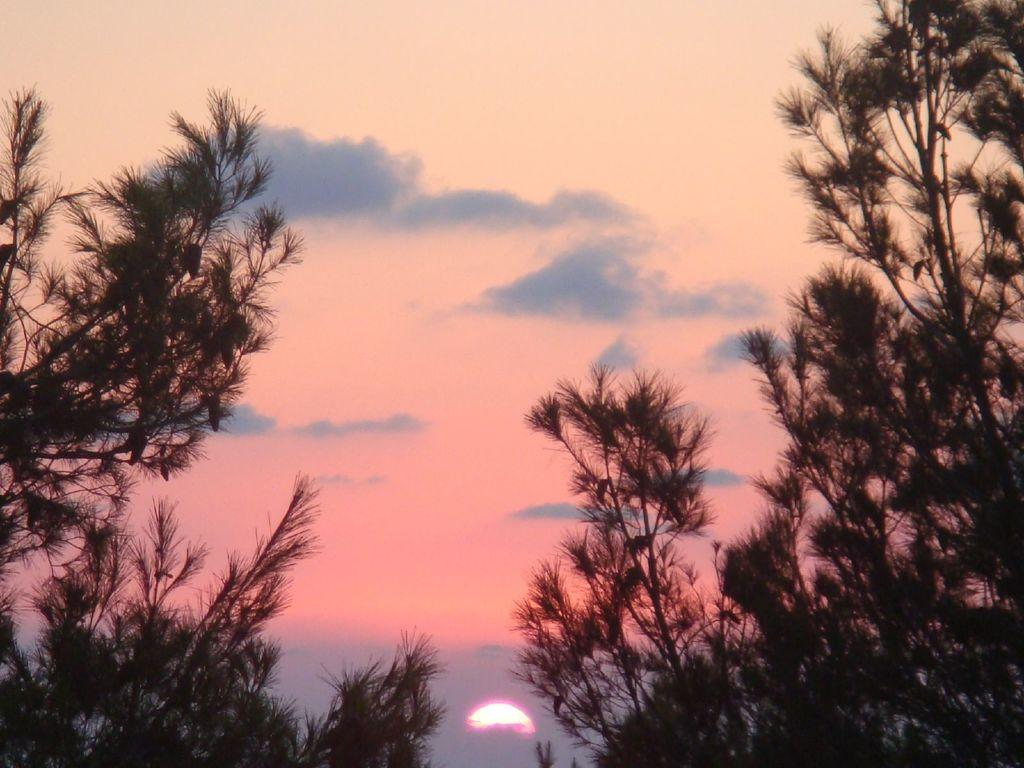What type of vegetation can be seen in the image? There are trees in the image. What is visible in the background of the image? There is a sky visible in the background of the image. Can the sun be seen in the image? Yes, the sun is observable in the sky. What else can be seen in the sky? There are clouds in the sky. What riddle does the stranger ask the trees in the image? There is no stranger present in the image, and therefore no riddle can be asked. 